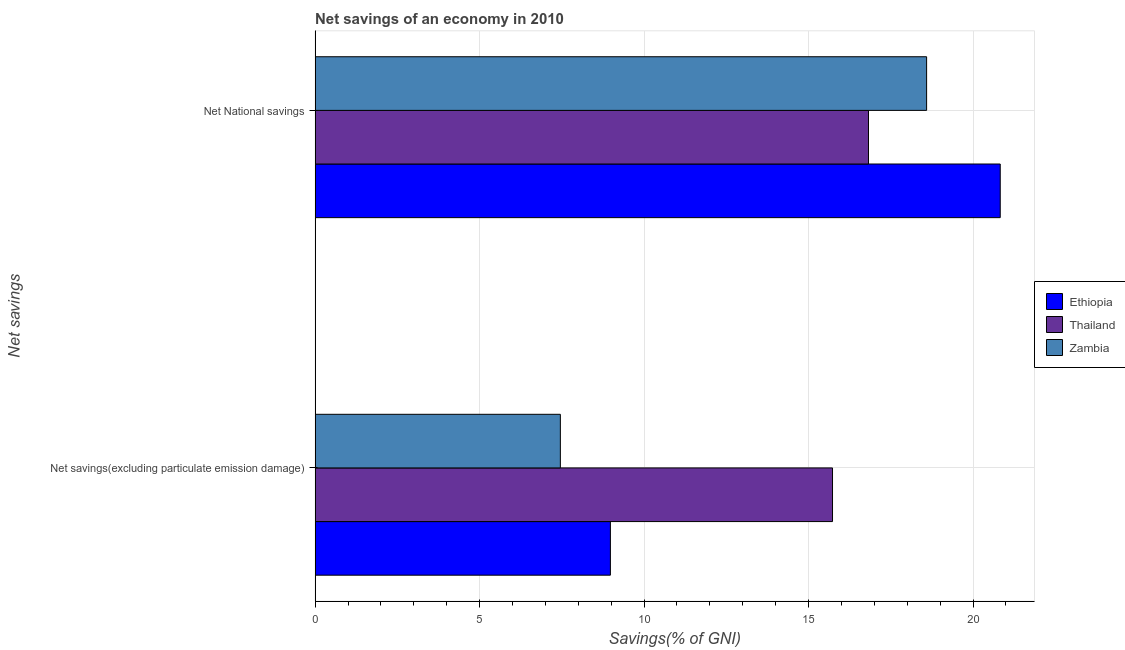How many bars are there on the 2nd tick from the bottom?
Offer a terse response. 3. What is the label of the 2nd group of bars from the top?
Offer a terse response. Net savings(excluding particulate emission damage). What is the net savings(excluding particulate emission damage) in Thailand?
Keep it short and to the point. 15.73. Across all countries, what is the maximum net national savings?
Your answer should be compact. 20.83. Across all countries, what is the minimum net savings(excluding particulate emission damage)?
Make the answer very short. 7.46. In which country was the net savings(excluding particulate emission damage) maximum?
Make the answer very short. Thailand. In which country was the net savings(excluding particulate emission damage) minimum?
Make the answer very short. Zambia. What is the total net savings(excluding particulate emission damage) in the graph?
Ensure brevity in your answer.  32.16. What is the difference between the net national savings in Thailand and that in Ethiopia?
Provide a short and direct response. -4.01. What is the difference between the net national savings in Ethiopia and the net savings(excluding particulate emission damage) in Zambia?
Your answer should be compact. 13.37. What is the average net national savings per country?
Ensure brevity in your answer.  18.74. What is the difference between the net savings(excluding particulate emission damage) and net national savings in Ethiopia?
Give a very brief answer. -11.85. In how many countries, is the net national savings greater than 16 %?
Offer a very short reply. 3. What is the ratio of the net national savings in Ethiopia to that in Thailand?
Ensure brevity in your answer.  1.24. In how many countries, is the net national savings greater than the average net national savings taken over all countries?
Ensure brevity in your answer.  1. What does the 3rd bar from the top in Net savings(excluding particulate emission damage) represents?
Your response must be concise. Ethiopia. What does the 1st bar from the bottom in Net National savings represents?
Offer a very short reply. Ethiopia. How many bars are there?
Provide a succinct answer. 6. How many countries are there in the graph?
Offer a very short reply. 3. Where does the legend appear in the graph?
Your answer should be very brief. Center right. How are the legend labels stacked?
Give a very brief answer. Vertical. What is the title of the graph?
Your response must be concise. Net savings of an economy in 2010. Does "Dominica" appear as one of the legend labels in the graph?
Keep it short and to the point. No. What is the label or title of the X-axis?
Your answer should be very brief. Savings(% of GNI). What is the label or title of the Y-axis?
Your answer should be very brief. Net savings. What is the Savings(% of GNI) in Ethiopia in Net savings(excluding particulate emission damage)?
Offer a terse response. 8.98. What is the Savings(% of GNI) in Thailand in Net savings(excluding particulate emission damage)?
Offer a very short reply. 15.73. What is the Savings(% of GNI) of Zambia in Net savings(excluding particulate emission damage)?
Offer a terse response. 7.46. What is the Savings(% of GNI) of Ethiopia in Net National savings?
Give a very brief answer. 20.83. What is the Savings(% of GNI) in Thailand in Net National savings?
Give a very brief answer. 16.82. What is the Savings(% of GNI) in Zambia in Net National savings?
Your answer should be compact. 18.59. Across all Net savings, what is the maximum Savings(% of GNI) of Ethiopia?
Make the answer very short. 20.83. Across all Net savings, what is the maximum Savings(% of GNI) of Thailand?
Offer a terse response. 16.82. Across all Net savings, what is the maximum Savings(% of GNI) of Zambia?
Keep it short and to the point. 18.59. Across all Net savings, what is the minimum Savings(% of GNI) in Ethiopia?
Offer a terse response. 8.98. Across all Net savings, what is the minimum Savings(% of GNI) of Thailand?
Offer a terse response. 15.73. Across all Net savings, what is the minimum Savings(% of GNI) of Zambia?
Offer a very short reply. 7.46. What is the total Savings(% of GNI) in Ethiopia in the graph?
Give a very brief answer. 29.8. What is the total Savings(% of GNI) of Thailand in the graph?
Ensure brevity in your answer.  32.55. What is the total Savings(% of GNI) of Zambia in the graph?
Offer a very short reply. 26.04. What is the difference between the Savings(% of GNI) of Ethiopia in Net savings(excluding particulate emission damage) and that in Net National savings?
Your answer should be very brief. -11.85. What is the difference between the Savings(% of GNI) of Thailand in Net savings(excluding particulate emission damage) and that in Net National savings?
Provide a short and direct response. -1.09. What is the difference between the Savings(% of GNI) in Zambia in Net savings(excluding particulate emission damage) and that in Net National savings?
Provide a short and direct response. -11.13. What is the difference between the Savings(% of GNI) in Ethiopia in Net savings(excluding particulate emission damage) and the Savings(% of GNI) in Thailand in Net National savings?
Ensure brevity in your answer.  -7.85. What is the difference between the Savings(% of GNI) of Ethiopia in Net savings(excluding particulate emission damage) and the Savings(% of GNI) of Zambia in Net National savings?
Give a very brief answer. -9.61. What is the difference between the Savings(% of GNI) in Thailand in Net savings(excluding particulate emission damage) and the Savings(% of GNI) in Zambia in Net National savings?
Provide a succinct answer. -2.86. What is the average Savings(% of GNI) in Ethiopia per Net savings?
Your answer should be very brief. 14.9. What is the average Savings(% of GNI) of Thailand per Net savings?
Provide a succinct answer. 16.27. What is the average Savings(% of GNI) in Zambia per Net savings?
Your answer should be compact. 13.02. What is the difference between the Savings(% of GNI) in Ethiopia and Savings(% of GNI) in Thailand in Net savings(excluding particulate emission damage)?
Keep it short and to the point. -6.75. What is the difference between the Savings(% of GNI) of Ethiopia and Savings(% of GNI) of Zambia in Net savings(excluding particulate emission damage)?
Your answer should be very brief. 1.52. What is the difference between the Savings(% of GNI) of Thailand and Savings(% of GNI) of Zambia in Net savings(excluding particulate emission damage)?
Offer a very short reply. 8.27. What is the difference between the Savings(% of GNI) in Ethiopia and Savings(% of GNI) in Thailand in Net National savings?
Your answer should be compact. 4. What is the difference between the Savings(% of GNI) of Ethiopia and Savings(% of GNI) of Zambia in Net National savings?
Offer a very short reply. 2.24. What is the difference between the Savings(% of GNI) in Thailand and Savings(% of GNI) in Zambia in Net National savings?
Offer a terse response. -1.77. What is the ratio of the Savings(% of GNI) in Ethiopia in Net savings(excluding particulate emission damage) to that in Net National savings?
Make the answer very short. 0.43. What is the ratio of the Savings(% of GNI) in Thailand in Net savings(excluding particulate emission damage) to that in Net National savings?
Offer a very short reply. 0.94. What is the ratio of the Savings(% of GNI) of Zambia in Net savings(excluding particulate emission damage) to that in Net National savings?
Provide a short and direct response. 0.4. What is the difference between the highest and the second highest Savings(% of GNI) in Ethiopia?
Ensure brevity in your answer.  11.85. What is the difference between the highest and the second highest Savings(% of GNI) in Thailand?
Offer a very short reply. 1.09. What is the difference between the highest and the second highest Savings(% of GNI) in Zambia?
Your response must be concise. 11.13. What is the difference between the highest and the lowest Savings(% of GNI) of Ethiopia?
Give a very brief answer. 11.85. What is the difference between the highest and the lowest Savings(% of GNI) in Thailand?
Your response must be concise. 1.09. What is the difference between the highest and the lowest Savings(% of GNI) of Zambia?
Give a very brief answer. 11.13. 